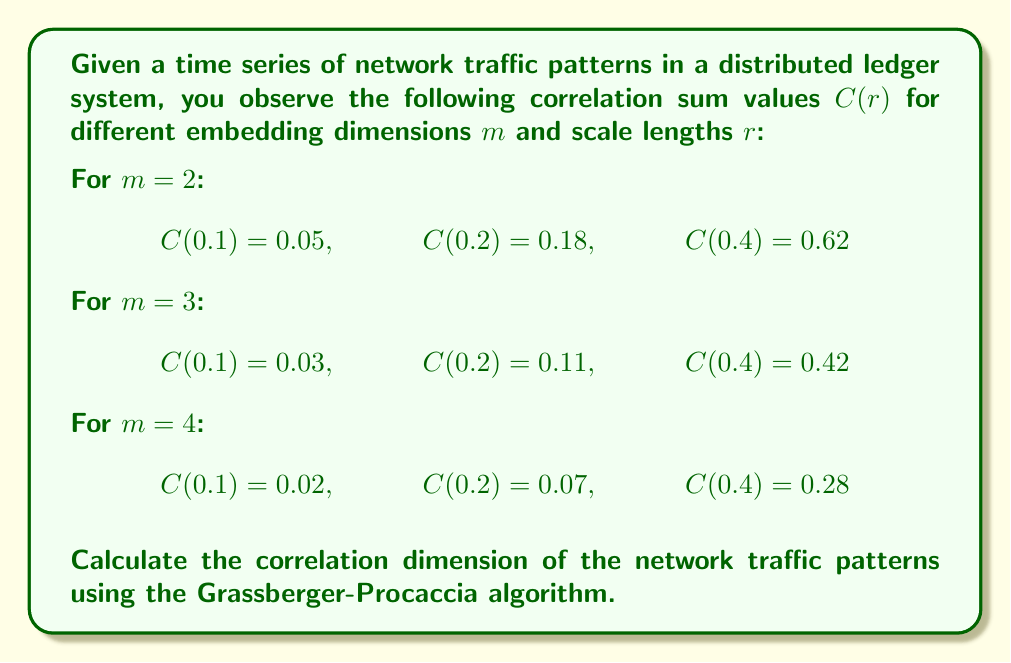Help me with this question. To calculate the correlation dimension using the Grassberger-Procaccia algorithm, we follow these steps:

1. For each embedding dimension m, plot log(C(r)) vs log(r).

2. Calculate the slope of each line using linear regression.

3. Plot the slopes against the embedding dimensions.

4. The correlation dimension is the value to which the slopes converge as m increases.

Let's go through each step:

Step 1: Plot log(C(r)) vs log(r) for each m

For m = 2:
$$\begin{array}{c|c|c}
\log(r) & \log(C(r)) \\
\hline
-1 & -1.30103 \\
-0.69897 & -0.74473 \\
-0.39794 & -0.20761
\end{array}$$

For m = 3:
$$\begin{array}{c|c|c}
\log(r) & \log(C(r)) \\
\hline
-1 & -1.52288 \\
-0.69897 & -0.95861 \\
-0.39794 & -0.37675
\end{array}$$

For m = 4:
$$\begin{array}{c|c|c}
\log(r) & \log(C(r)) \\
\hline
-1 & -1.69897 \\
-0.69897 & -1.15490 \\
-0.39794 & -0.55284
\end{array}$$

Step 2: Calculate the slopes using linear regression

For m = 2: slope ≈ 1.82
For m = 3: slope ≈ 1.91
For m = 4: slope ≈ 1.92

Step 3: Plot the slopes against the embedding dimensions

[asy]
size(200,150);
real[] x = {2,3,4};
real[] y = {1.82,1.91,1.92};
for(int i=0; i<3; ++i) {
  dot((x[i],y[i]));
}
draw(graph(x,y));
xaxis("m",0,5,Arrow);
yaxis("Slope",0,2,Arrow);
[/asy]

Step 4: Determine the correlation dimension

The slopes appear to converge to a value around 1.92 as m increases. Therefore, we can estimate the correlation dimension to be approximately 1.92.
Answer: 1.92 